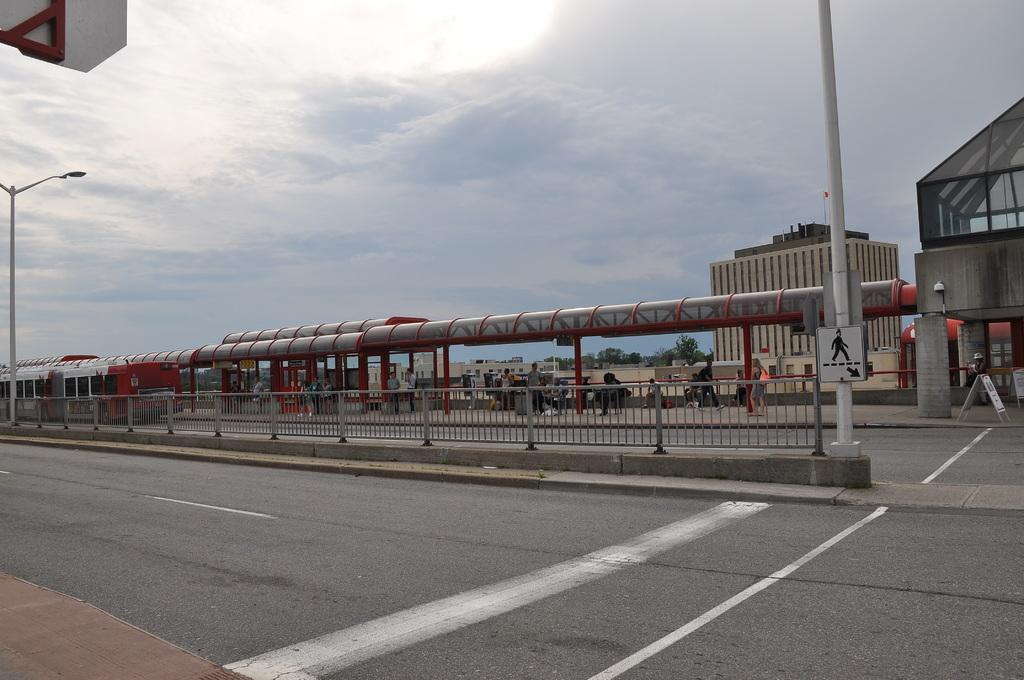What type of road is shown in the image? The image shows a two-way road. What are the people on the road doing? There are people walking on the sidewalk. Are there any people sitting in the image? Yes, some people are seated on a bench. What can be seen in the background of the image? There are buildings visible in the image. What type of vegetation is present in the image? Trees are present in the image. What type of lighting is used along the road? Pole lights are in the image. How would you describe the weather in the image? The sky is cloudy in the image. What type of yam is being sold at the store in the image? There is no store or yam present in the image. What is the quill used for by the person sitting on the bench? There is no quill present in the image, and no one is using a quill for any purpose. 